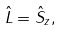Convert formula to latex. <formula><loc_0><loc_0><loc_500><loc_500>\hat { L } = \hat { S } _ { z } ,</formula> 